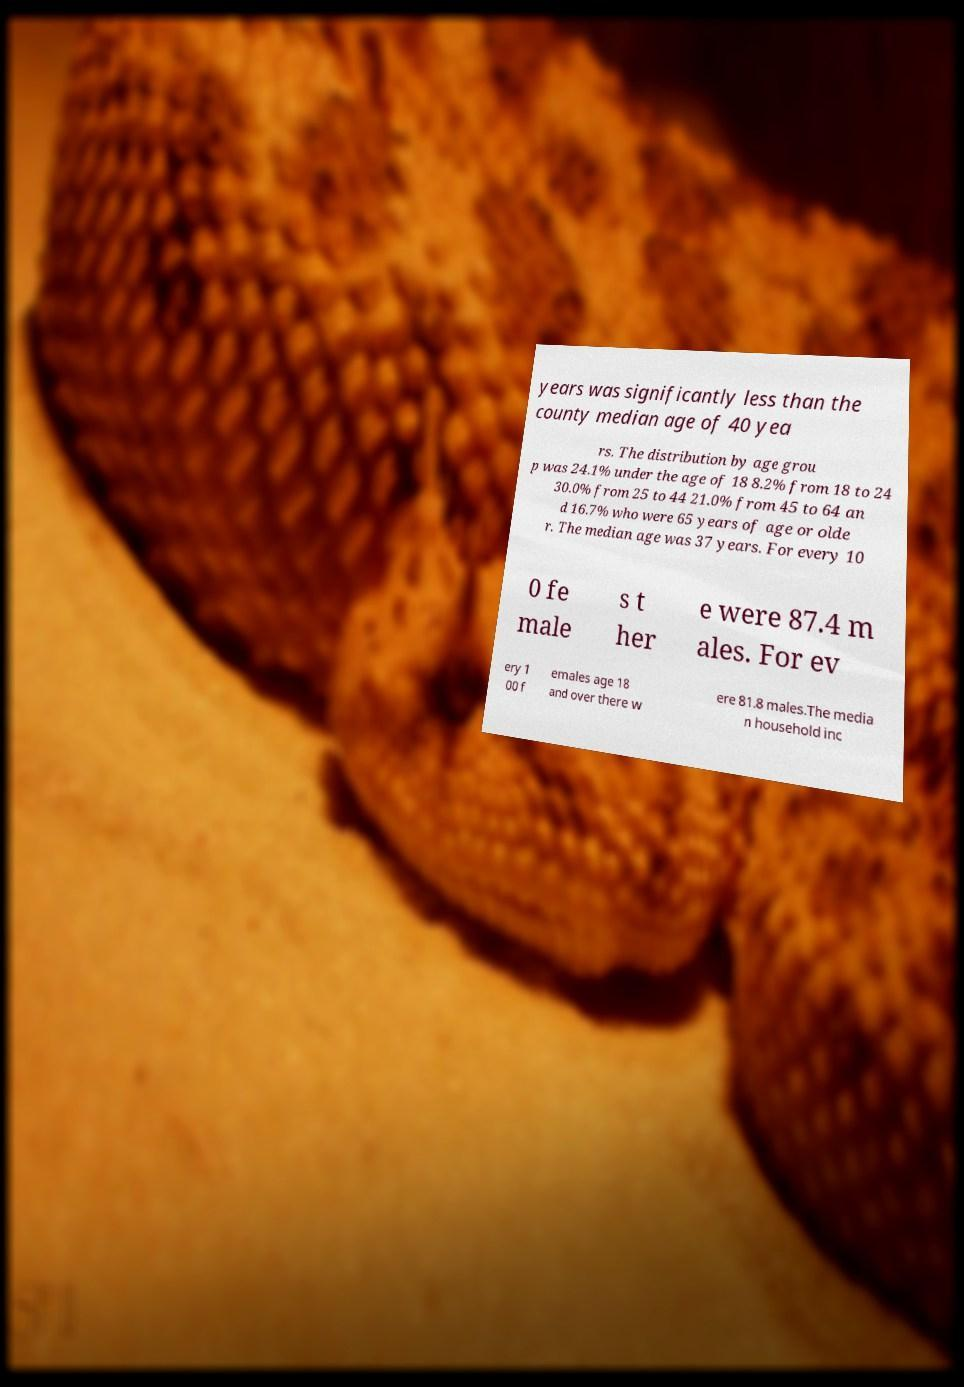Could you extract and type out the text from this image? years was significantly less than the county median age of 40 yea rs. The distribution by age grou p was 24.1% under the age of 18 8.2% from 18 to 24 30.0% from 25 to 44 21.0% from 45 to 64 an d 16.7% who were 65 years of age or olde r. The median age was 37 years. For every 10 0 fe male s t her e were 87.4 m ales. For ev ery 1 00 f emales age 18 and over there w ere 81.8 males.The media n household inc 